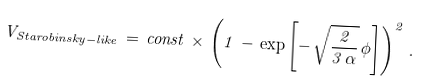Convert formula to latex. <formula><loc_0><loc_0><loc_500><loc_500>V _ { S t a r o b i n s k y - l i k e } \, = \, c o n s t \, \times \, \left ( 1 \, - \, \exp \left [ - \, \sqrt { \frac { 2 } { 3 \, \alpha } } \, \phi \right ] \right ) ^ { 2 } \, .</formula> 